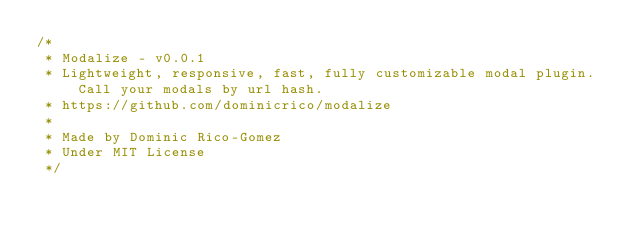<code> <loc_0><loc_0><loc_500><loc_500><_JavaScript_>/*
 * Modalize - v0.0.1
 * Lightweight, responsive, fast, fully customizable modal plugin. Call your modals by url hash.
 * https://github.com/dominicrico/modalize
 *
 * Made by Dominic Rico-Gomez
 * Under MIT License
 */
</code> 